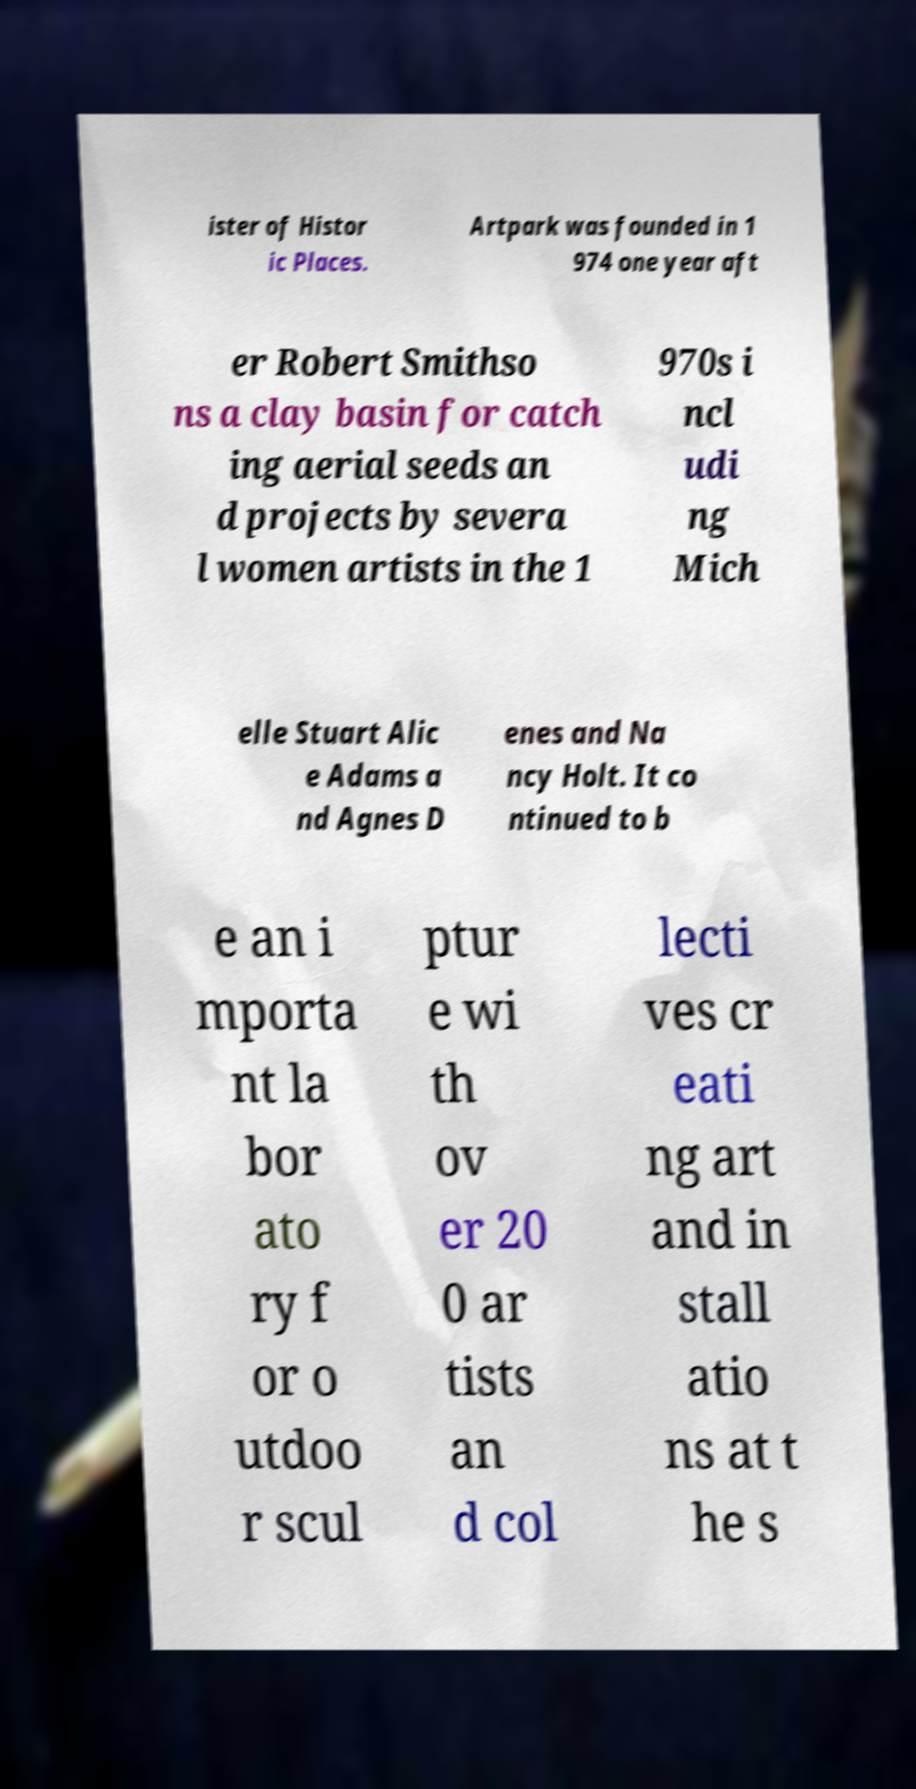What messages or text are displayed in this image? I need them in a readable, typed format. ister of Histor ic Places. Artpark was founded in 1 974 one year aft er Robert Smithso ns a clay basin for catch ing aerial seeds an d projects by severa l women artists in the 1 970s i ncl udi ng Mich elle Stuart Alic e Adams a nd Agnes D enes and Na ncy Holt. It co ntinued to b e an i mporta nt la bor ato ry f or o utdoo r scul ptur e wi th ov er 20 0 ar tists an d col lecti ves cr eati ng art and in stall atio ns at t he s 